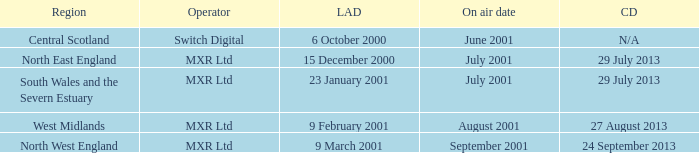What is the license award date for North East England? 15 December 2000. 